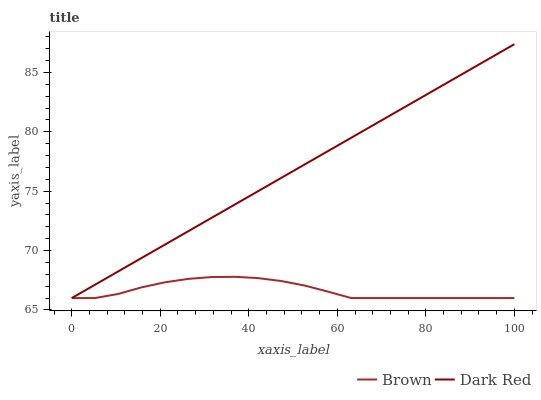Does Brown have the minimum area under the curve?
Answer yes or no. Yes. Does Dark Red have the maximum area under the curve?
Answer yes or no. Yes. Does Dark Red have the minimum area under the curve?
Answer yes or no. No. Is Dark Red the smoothest?
Answer yes or no. Yes. Is Brown the roughest?
Answer yes or no. Yes. Is Dark Red the roughest?
Answer yes or no. No. Does Brown have the lowest value?
Answer yes or no. Yes. Does Dark Red have the highest value?
Answer yes or no. Yes. Does Dark Red intersect Brown?
Answer yes or no. Yes. Is Dark Red less than Brown?
Answer yes or no. No. Is Dark Red greater than Brown?
Answer yes or no. No. 